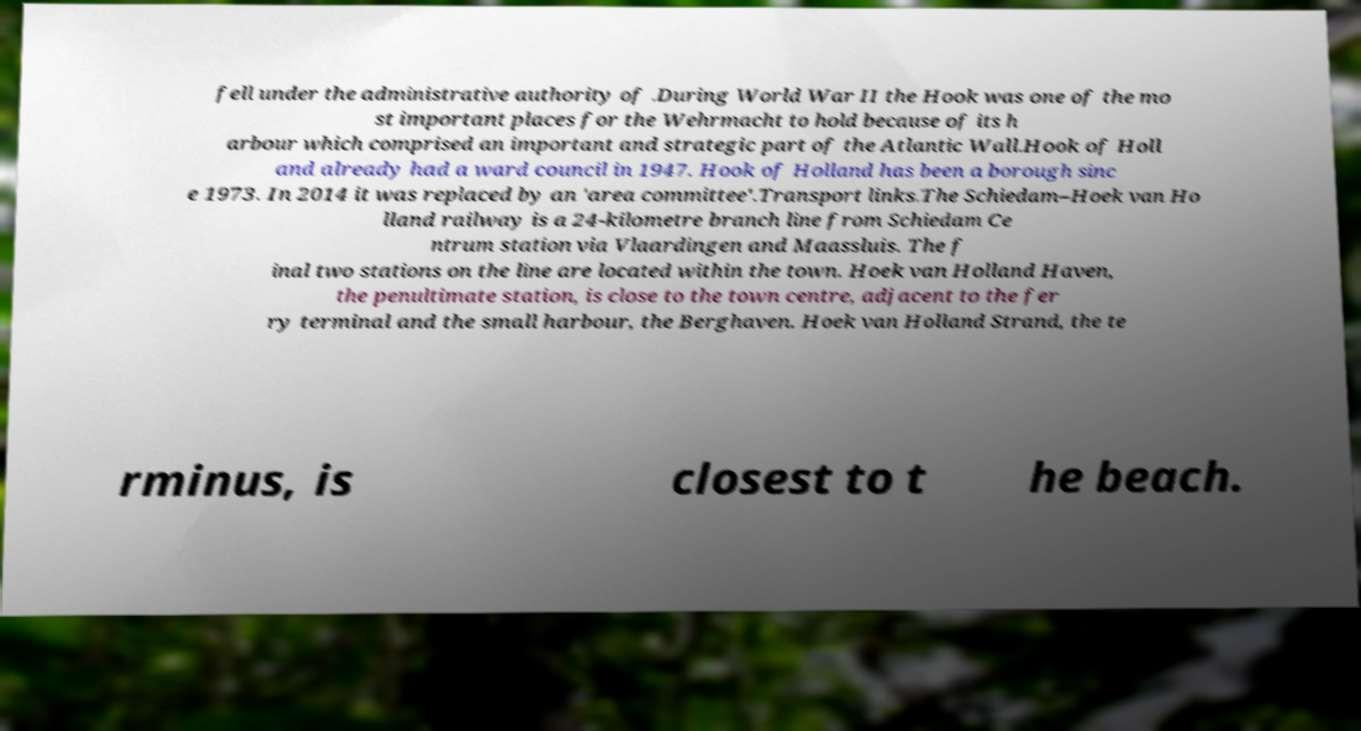Please identify and transcribe the text found in this image. fell under the administrative authority of .During World War II the Hook was one of the mo st important places for the Wehrmacht to hold because of its h arbour which comprised an important and strategic part of the Atlantic Wall.Hook of Holl and already had a ward council in 1947. Hook of Holland has been a borough sinc e 1973. In 2014 it was replaced by an 'area committee'.Transport links.The Schiedam–Hoek van Ho lland railway is a 24-kilometre branch line from Schiedam Ce ntrum station via Vlaardingen and Maassluis. The f inal two stations on the line are located within the town. Hoek van Holland Haven, the penultimate station, is close to the town centre, adjacent to the fer ry terminal and the small harbour, the Berghaven. Hoek van Holland Strand, the te rminus, is closest to t he beach. 